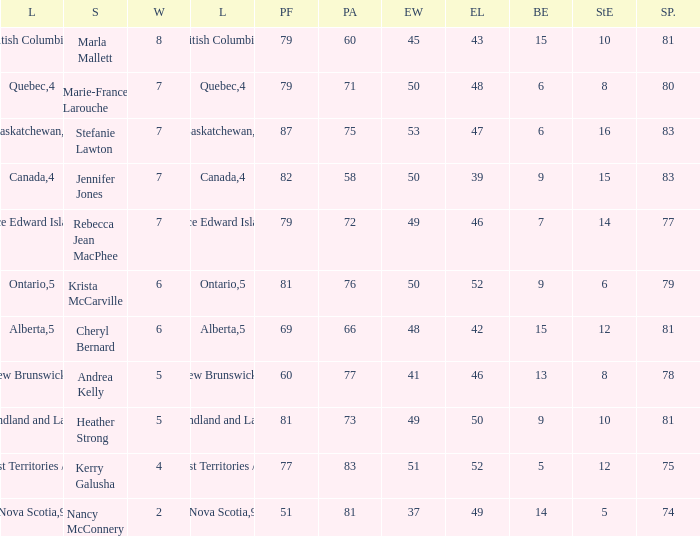What is the pf for Rebecca Jean Macphee? 79.0. 